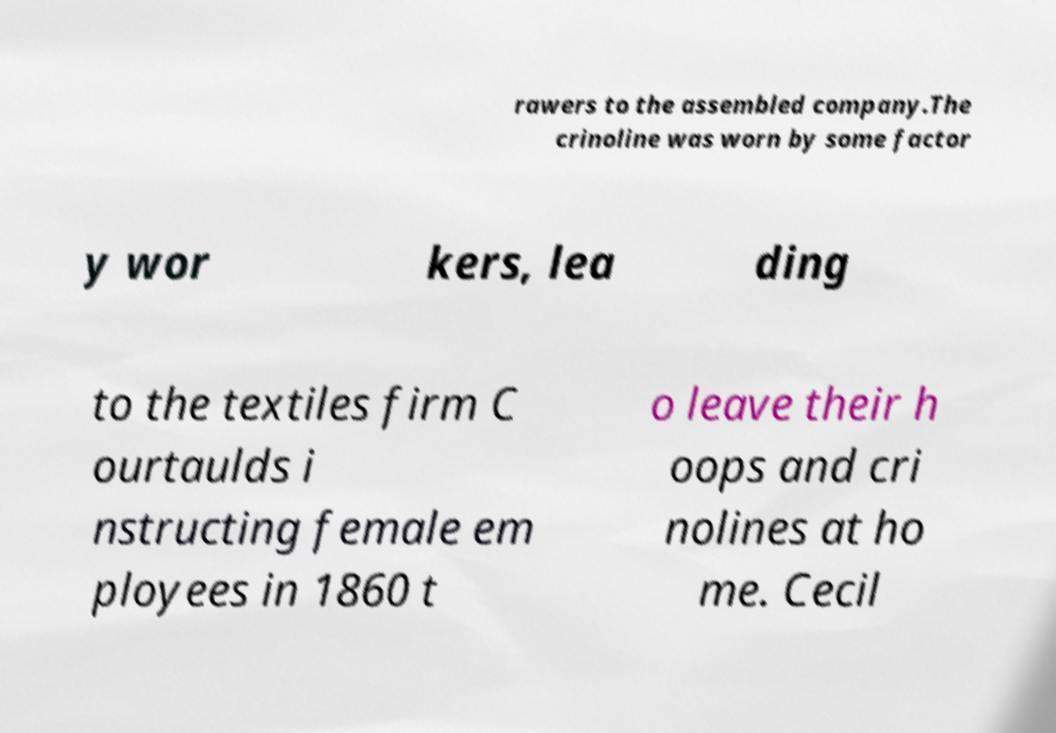For documentation purposes, I need the text within this image transcribed. Could you provide that? rawers to the assembled company.The crinoline was worn by some factor y wor kers, lea ding to the textiles firm C ourtaulds i nstructing female em ployees in 1860 t o leave their h oops and cri nolines at ho me. Cecil 